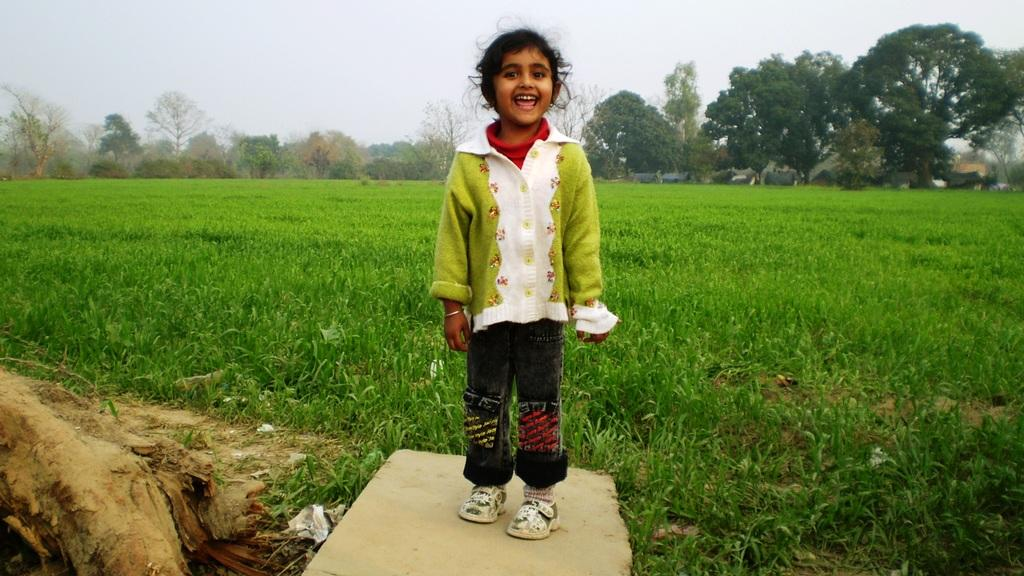Who is present in the image? There is a girl in the image. What is the girl doing in the image? The girl is standing on a cement block and smiling. What type of surface is the girl standing on? The girl is standing on a cement block. What is the natural environment like in the image? There is grass on the ground and trees in the background of the image. What can be seen in the sky in the image? The sky is visible in the background of the image. What type of animal is the girl rewarding with a street in the image? There is no animal present in the image, nor is there any mention of a street or a reward. 